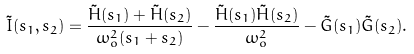Convert formula to latex. <formula><loc_0><loc_0><loc_500><loc_500>\tilde { I } ( s _ { 1 } , s _ { 2 } ) = \frac { \tilde { H } ( s _ { 1 } ) + \tilde { H } ( s _ { 2 } ) } { \omega _ { o } ^ { 2 } ( s _ { 1 } + s _ { 2 } ) } - \frac { \tilde { H } ( s _ { 1 } ) \tilde { H } ( s _ { 2 } ) } { \omega _ { o } ^ { 2 } } - \tilde { G } ( s _ { 1 } ) \tilde { G } ( s _ { 2 } ) .</formula> 